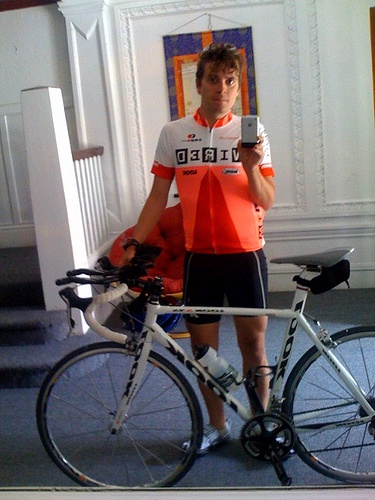Describe the objects in this image and their specific colors. I can see bicycle in black and gray tones, people in black, maroon, brown, and darkgray tones, chair in black, maroon, and brown tones, bottle in black and gray tones, and cell phone in black, gray, lightgray, and darkgray tones in this image. 